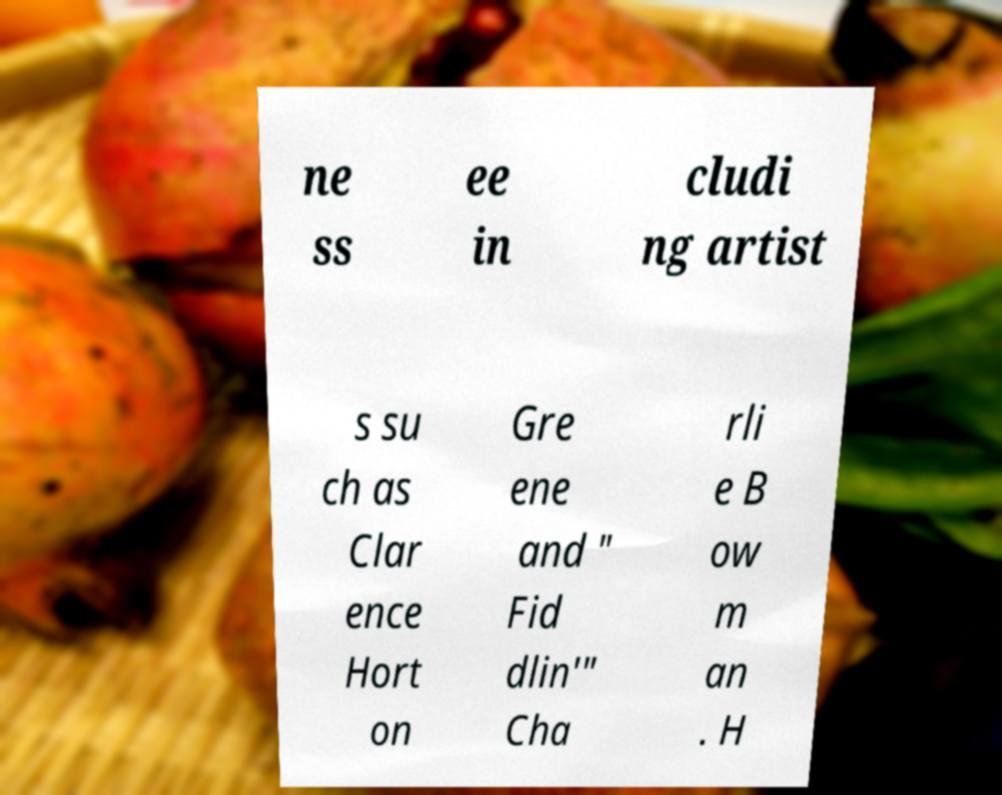Can you accurately transcribe the text from the provided image for me? ne ss ee in cludi ng artist s su ch as Clar ence Hort on Gre ene and " Fid dlin'" Cha rli e B ow m an . H 